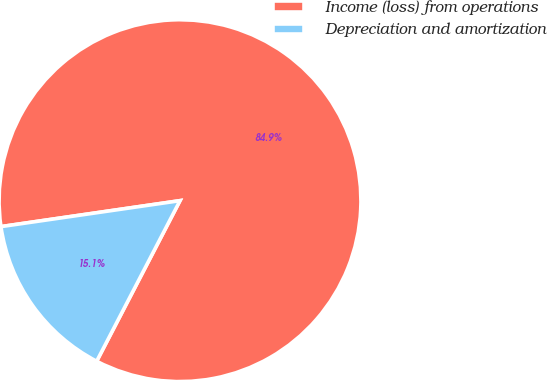<chart> <loc_0><loc_0><loc_500><loc_500><pie_chart><fcel>Income (loss) from operations<fcel>Depreciation and amortization<nl><fcel>84.91%<fcel>15.09%<nl></chart> 